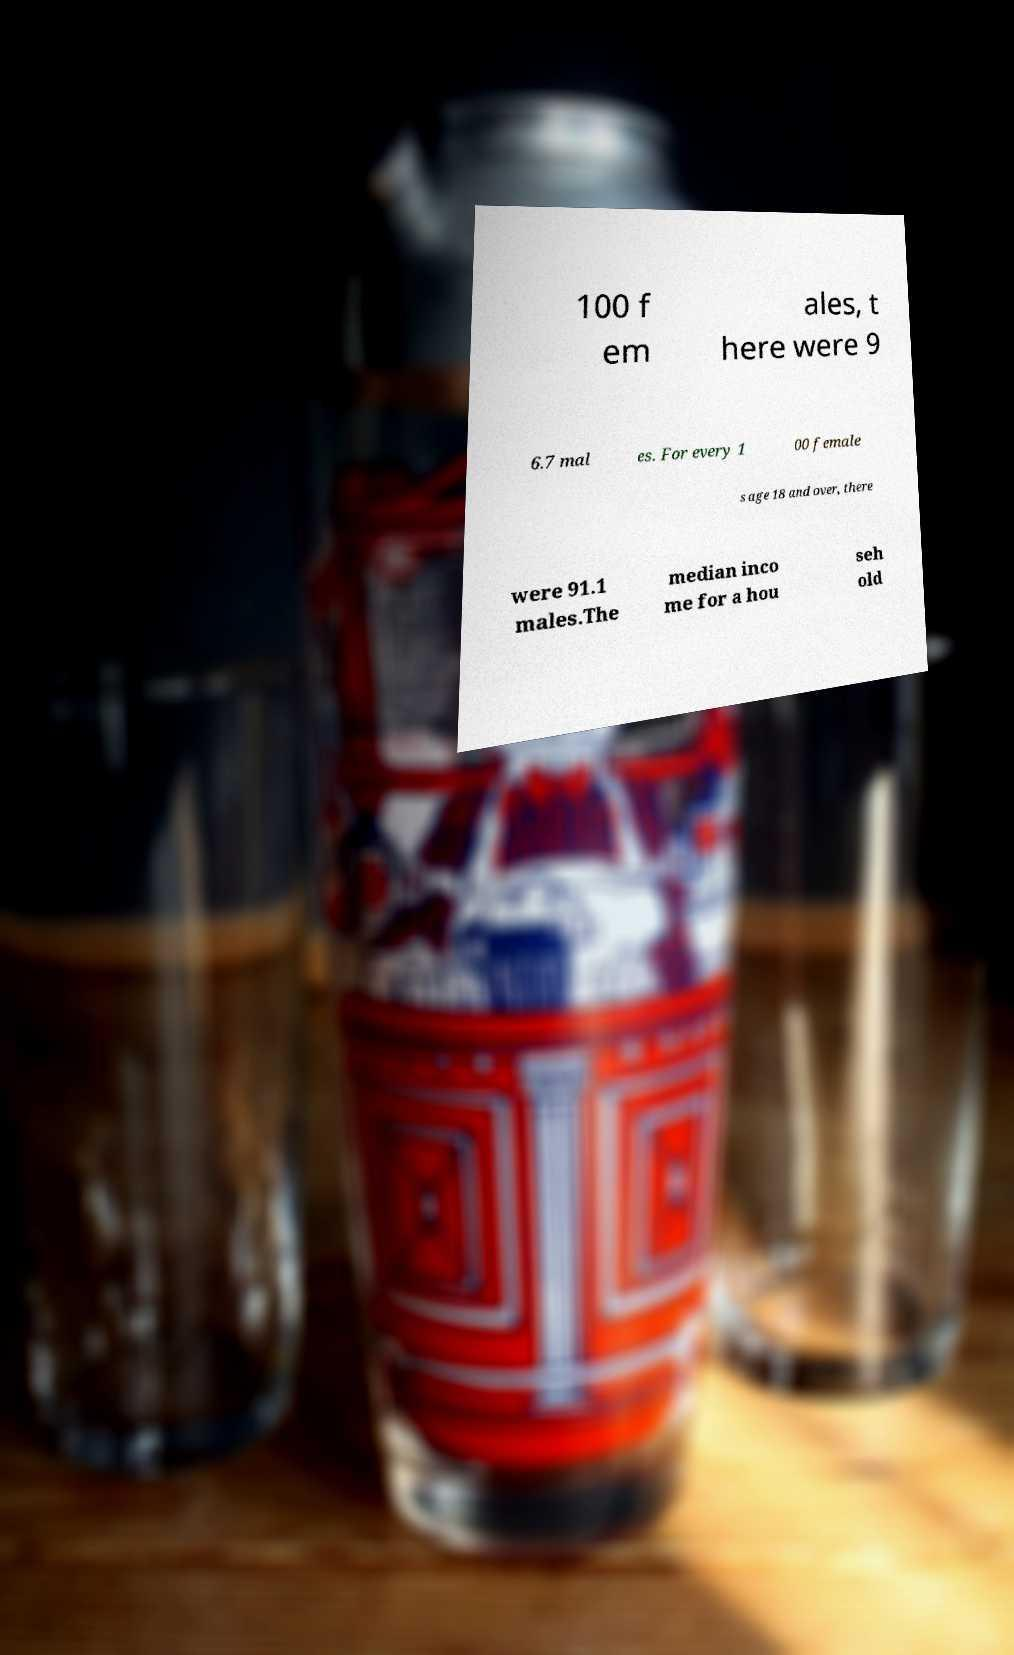Please read and relay the text visible in this image. What does it say? 100 f em ales, t here were 9 6.7 mal es. For every 1 00 female s age 18 and over, there were 91.1 males.The median inco me for a hou seh old 